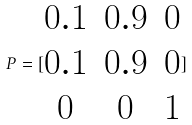Convert formula to latex. <formula><loc_0><loc_0><loc_500><loc_500>P = [ \begin{matrix} 0 . 1 & 0 . 9 & 0 \\ 0 . 1 & 0 . 9 & 0 \\ 0 & 0 & 1 \end{matrix} ]</formula> 